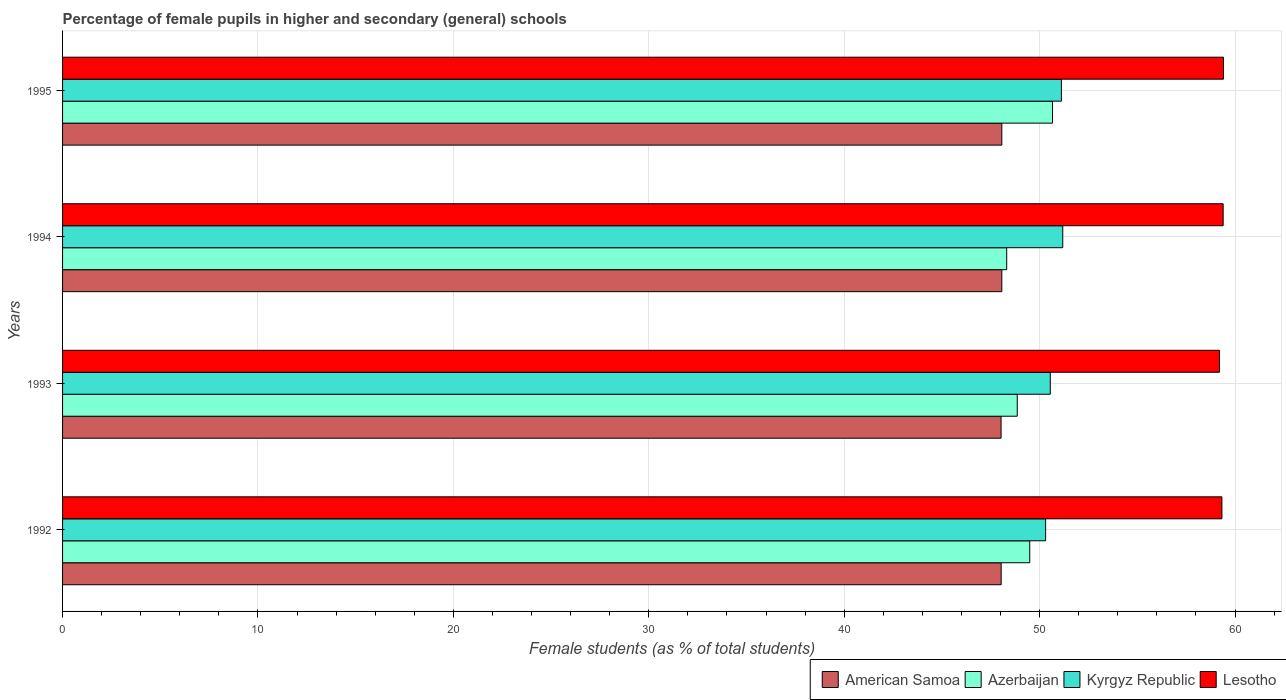How many different coloured bars are there?
Your answer should be very brief. 4. Are the number of bars per tick equal to the number of legend labels?
Offer a very short reply. Yes. Are the number of bars on each tick of the Y-axis equal?
Make the answer very short. Yes. What is the label of the 2nd group of bars from the top?
Provide a short and direct response. 1994. In how many cases, is the number of bars for a given year not equal to the number of legend labels?
Provide a short and direct response. 0. What is the percentage of female pupils in higher and secondary schools in Lesotho in 1992?
Your response must be concise. 59.33. Across all years, what is the maximum percentage of female pupils in higher and secondary schools in Lesotho?
Offer a terse response. 59.41. Across all years, what is the minimum percentage of female pupils in higher and secondary schools in Azerbaijan?
Give a very brief answer. 48.32. In which year was the percentage of female pupils in higher and secondary schools in American Samoa maximum?
Provide a short and direct response. 1994. What is the total percentage of female pupils in higher and secondary schools in Azerbaijan in the graph?
Ensure brevity in your answer.  197.33. What is the difference between the percentage of female pupils in higher and secondary schools in Kyrgyz Republic in 1992 and that in 1993?
Keep it short and to the point. -0.24. What is the difference between the percentage of female pupils in higher and secondary schools in American Samoa in 1993 and the percentage of female pupils in higher and secondary schools in Azerbaijan in 1992?
Provide a succinct answer. -1.47. What is the average percentage of female pupils in higher and secondary schools in Azerbaijan per year?
Give a very brief answer. 49.33. In the year 1994, what is the difference between the percentage of female pupils in higher and secondary schools in American Samoa and percentage of female pupils in higher and secondary schools in Azerbaijan?
Provide a succinct answer. -0.25. In how many years, is the percentage of female pupils in higher and secondary schools in Kyrgyz Republic greater than 12 %?
Make the answer very short. 4. What is the ratio of the percentage of female pupils in higher and secondary schools in Kyrgyz Republic in 1994 to that in 1995?
Keep it short and to the point. 1. Is the percentage of female pupils in higher and secondary schools in Azerbaijan in 1992 less than that in 1995?
Offer a terse response. Yes. What is the difference between the highest and the second highest percentage of female pupils in higher and secondary schools in Azerbaijan?
Offer a terse response. 1.17. What is the difference between the highest and the lowest percentage of female pupils in higher and secondary schools in Azerbaijan?
Provide a short and direct response. 2.34. In how many years, is the percentage of female pupils in higher and secondary schools in Azerbaijan greater than the average percentage of female pupils in higher and secondary schools in Azerbaijan taken over all years?
Provide a succinct answer. 2. Is the sum of the percentage of female pupils in higher and secondary schools in American Samoa in 1992 and 1994 greater than the maximum percentage of female pupils in higher and secondary schools in Kyrgyz Republic across all years?
Your response must be concise. Yes. Is it the case that in every year, the sum of the percentage of female pupils in higher and secondary schools in Kyrgyz Republic and percentage of female pupils in higher and secondary schools in Lesotho is greater than the sum of percentage of female pupils in higher and secondary schools in Azerbaijan and percentage of female pupils in higher and secondary schools in American Samoa?
Offer a terse response. Yes. What does the 4th bar from the top in 1993 represents?
Provide a short and direct response. American Samoa. What does the 1st bar from the bottom in 1993 represents?
Your answer should be very brief. American Samoa. Is it the case that in every year, the sum of the percentage of female pupils in higher and secondary schools in American Samoa and percentage of female pupils in higher and secondary schools in Azerbaijan is greater than the percentage of female pupils in higher and secondary schools in Lesotho?
Offer a very short reply. Yes. Are all the bars in the graph horizontal?
Offer a very short reply. Yes. How many years are there in the graph?
Offer a very short reply. 4. Does the graph contain any zero values?
Give a very brief answer. No. What is the title of the graph?
Ensure brevity in your answer.  Percentage of female pupils in higher and secondary (general) schools. Does "Upper middle income" appear as one of the legend labels in the graph?
Your response must be concise. No. What is the label or title of the X-axis?
Your answer should be very brief. Female students (as % of total students). What is the Female students (as % of total students) in American Samoa in 1992?
Make the answer very short. 48.03. What is the Female students (as % of total students) of Azerbaijan in 1992?
Your answer should be very brief. 49.5. What is the Female students (as % of total students) in Kyrgyz Republic in 1992?
Your response must be concise. 50.31. What is the Female students (as % of total students) of Lesotho in 1992?
Ensure brevity in your answer.  59.33. What is the Female students (as % of total students) of American Samoa in 1993?
Provide a short and direct response. 48.03. What is the Female students (as % of total students) of Azerbaijan in 1993?
Keep it short and to the point. 48.86. What is the Female students (as % of total students) in Kyrgyz Republic in 1993?
Make the answer very short. 50.55. What is the Female students (as % of total students) in Lesotho in 1993?
Keep it short and to the point. 59.2. What is the Female students (as % of total students) of American Samoa in 1994?
Provide a succinct answer. 48.07. What is the Female students (as % of total students) in Azerbaijan in 1994?
Your answer should be compact. 48.32. What is the Female students (as % of total students) of Kyrgyz Republic in 1994?
Offer a terse response. 51.18. What is the Female students (as % of total students) of Lesotho in 1994?
Offer a terse response. 59.39. What is the Female students (as % of total students) of American Samoa in 1995?
Your answer should be very brief. 48.07. What is the Female students (as % of total students) of Azerbaijan in 1995?
Provide a short and direct response. 50.66. What is the Female students (as % of total students) in Kyrgyz Republic in 1995?
Ensure brevity in your answer.  51.12. What is the Female students (as % of total students) of Lesotho in 1995?
Ensure brevity in your answer.  59.41. Across all years, what is the maximum Female students (as % of total students) of American Samoa?
Make the answer very short. 48.07. Across all years, what is the maximum Female students (as % of total students) of Azerbaijan?
Your answer should be very brief. 50.66. Across all years, what is the maximum Female students (as % of total students) of Kyrgyz Republic?
Ensure brevity in your answer.  51.18. Across all years, what is the maximum Female students (as % of total students) of Lesotho?
Provide a short and direct response. 59.41. Across all years, what is the minimum Female students (as % of total students) of American Samoa?
Offer a terse response. 48.03. Across all years, what is the minimum Female students (as % of total students) of Azerbaijan?
Keep it short and to the point. 48.32. Across all years, what is the minimum Female students (as % of total students) in Kyrgyz Republic?
Your response must be concise. 50.31. Across all years, what is the minimum Female students (as % of total students) of Lesotho?
Provide a short and direct response. 59.2. What is the total Female students (as % of total students) in American Samoa in the graph?
Your answer should be compact. 192.19. What is the total Female students (as % of total students) in Azerbaijan in the graph?
Your response must be concise. 197.33. What is the total Female students (as % of total students) in Kyrgyz Republic in the graph?
Your answer should be compact. 203.15. What is the total Female students (as % of total students) in Lesotho in the graph?
Offer a very short reply. 237.33. What is the difference between the Female students (as % of total students) of American Samoa in 1992 and that in 1993?
Your answer should be compact. 0.01. What is the difference between the Female students (as % of total students) in Azerbaijan in 1992 and that in 1993?
Offer a terse response. 0.64. What is the difference between the Female students (as % of total students) in Kyrgyz Republic in 1992 and that in 1993?
Provide a short and direct response. -0.24. What is the difference between the Female students (as % of total students) of Lesotho in 1992 and that in 1993?
Provide a short and direct response. 0.13. What is the difference between the Female students (as % of total students) in American Samoa in 1992 and that in 1994?
Give a very brief answer. -0.03. What is the difference between the Female students (as % of total students) in Azerbaijan in 1992 and that in 1994?
Make the answer very short. 1.18. What is the difference between the Female students (as % of total students) of Kyrgyz Republic in 1992 and that in 1994?
Give a very brief answer. -0.88. What is the difference between the Female students (as % of total students) of Lesotho in 1992 and that in 1994?
Offer a terse response. -0.06. What is the difference between the Female students (as % of total students) of American Samoa in 1992 and that in 1995?
Keep it short and to the point. -0.03. What is the difference between the Female students (as % of total students) in Azerbaijan in 1992 and that in 1995?
Offer a terse response. -1.17. What is the difference between the Female students (as % of total students) of Kyrgyz Republic in 1992 and that in 1995?
Ensure brevity in your answer.  -0.81. What is the difference between the Female students (as % of total students) in Lesotho in 1992 and that in 1995?
Your answer should be compact. -0.08. What is the difference between the Female students (as % of total students) of American Samoa in 1993 and that in 1994?
Make the answer very short. -0.04. What is the difference between the Female students (as % of total students) of Azerbaijan in 1993 and that in 1994?
Your answer should be compact. 0.54. What is the difference between the Female students (as % of total students) of Kyrgyz Republic in 1993 and that in 1994?
Keep it short and to the point. -0.64. What is the difference between the Female students (as % of total students) in Lesotho in 1993 and that in 1994?
Provide a short and direct response. -0.19. What is the difference between the Female students (as % of total students) of American Samoa in 1993 and that in 1995?
Offer a very short reply. -0.04. What is the difference between the Female students (as % of total students) in Azerbaijan in 1993 and that in 1995?
Ensure brevity in your answer.  -1.81. What is the difference between the Female students (as % of total students) in Kyrgyz Republic in 1993 and that in 1995?
Offer a terse response. -0.57. What is the difference between the Female students (as % of total students) in Lesotho in 1993 and that in 1995?
Keep it short and to the point. -0.2. What is the difference between the Female students (as % of total students) in American Samoa in 1994 and that in 1995?
Ensure brevity in your answer.  0. What is the difference between the Female students (as % of total students) of Azerbaijan in 1994 and that in 1995?
Your answer should be compact. -2.34. What is the difference between the Female students (as % of total students) in Kyrgyz Republic in 1994 and that in 1995?
Keep it short and to the point. 0.07. What is the difference between the Female students (as % of total students) in Lesotho in 1994 and that in 1995?
Make the answer very short. -0.01. What is the difference between the Female students (as % of total students) in American Samoa in 1992 and the Female students (as % of total students) in Azerbaijan in 1993?
Your response must be concise. -0.82. What is the difference between the Female students (as % of total students) in American Samoa in 1992 and the Female students (as % of total students) in Kyrgyz Republic in 1993?
Offer a terse response. -2.51. What is the difference between the Female students (as % of total students) in American Samoa in 1992 and the Female students (as % of total students) in Lesotho in 1993?
Your answer should be very brief. -11.17. What is the difference between the Female students (as % of total students) of Azerbaijan in 1992 and the Female students (as % of total students) of Kyrgyz Republic in 1993?
Your answer should be very brief. -1.05. What is the difference between the Female students (as % of total students) of Azerbaijan in 1992 and the Female students (as % of total students) of Lesotho in 1993?
Keep it short and to the point. -9.71. What is the difference between the Female students (as % of total students) of Kyrgyz Republic in 1992 and the Female students (as % of total students) of Lesotho in 1993?
Give a very brief answer. -8.9. What is the difference between the Female students (as % of total students) of American Samoa in 1992 and the Female students (as % of total students) of Azerbaijan in 1994?
Give a very brief answer. -0.28. What is the difference between the Female students (as % of total students) in American Samoa in 1992 and the Female students (as % of total students) in Kyrgyz Republic in 1994?
Keep it short and to the point. -3.15. What is the difference between the Female students (as % of total students) of American Samoa in 1992 and the Female students (as % of total students) of Lesotho in 1994?
Your answer should be compact. -11.36. What is the difference between the Female students (as % of total students) of Azerbaijan in 1992 and the Female students (as % of total students) of Kyrgyz Republic in 1994?
Provide a short and direct response. -1.69. What is the difference between the Female students (as % of total students) in Azerbaijan in 1992 and the Female students (as % of total students) in Lesotho in 1994?
Keep it short and to the point. -9.9. What is the difference between the Female students (as % of total students) of Kyrgyz Republic in 1992 and the Female students (as % of total students) of Lesotho in 1994?
Your response must be concise. -9.08. What is the difference between the Female students (as % of total students) of American Samoa in 1992 and the Female students (as % of total students) of Azerbaijan in 1995?
Your response must be concise. -2.63. What is the difference between the Female students (as % of total students) in American Samoa in 1992 and the Female students (as % of total students) in Kyrgyz Republic in 1995?
Offer a terse response. -3.08. What is the difference between the Female students (as % of total students) of American Samoa in 1992 and the Female students (as % of total students) of Lesotho in 1995?
Offer a very short reply. -11.37. What is the difference between the Female students (as % of total students) of Azerbaijan in 1992 and the Female students (as % of total students) of Kyrgyz Republic in 1995?
Your response must be concise. -1.62. What is the difference between the Female students (as % of total students) in Azerbaijan in 1992 and the Female students (as % of total students) in Lesotho in 1995?
Make the answer very short. -9.91. What is the difference between the Female students (as % of total students) in Kyrgyz Republic in 1992 and the Female students (as % of total students) in Lesotho in 1995?
Your answer should be compact. -9.1. What is the difference between the Female students (as % of total students) in American Samoa in 1993 and the Female students (as % of total students) in Azerbaijan in 1994?
Offer a terse response. -0.29. What is the difference between the Female students (as % of total students) in American Samoa in 1993 and the Female students (as % of total students) in Kyrgyz Republic in 1994?
Provide a succinct answer. -3.16. What is the difference between the Female students (as % of total students) of American Samoa in 1993 and the Female students (as % of total students) of Lesotho in 1994?
Your answer should be very brief. -11.36. What is the difference between the Female students (as % of total students) of Azerbaijan in 1993 and the Female students (as % of total students) of Kyrgyz Republic in 1994?
Ensure brevity in your answer.  -2.33. What is the difference between the Female students (as % of total students) of Azerbaijan in 1993 and the Female students (as % of total students) of Lesotho in 1994?
Ensure brevity in your answer.  -10.54. What is the difference between the Female students (as % of total students) of Kyrgyz Republic in 1993 and the Female students (as % of total students) of Lesotho in 1994?
Offer a very short reply. -8.85. What is the difference between the Female students (as % of total students) of American Samoa in 1993 and the Female students (as % of total students) of Azerbaijan in 1995?
Your answer should be compact. -2.63. What is the difference between the Female students (as % of total students) of American Samoa in 1993 and the Female students (as % of total students) of Kyrgyz Republic in 1995?
Offer a very short reply. -3.09. What is the difference between the Female students (as % of total students) in American Samoa in 1993 and the Female students (as % of total students) in Lesotho in 1995?
Your answer should be compact. -11.38. What is the difference between the Female students (as % of total students) in Azerbaijan in 1993 and the Female students (as % of total students) in Kyrgyz Republic in 1995?
Provide a short and direct response. -2.26. What is the difference between the Female students (as % of total students) in Azerbaijan in 1993 and the Female students (as % of total students) in Lesotho in 1995?
Keep it short and to the point. -10.55. What is the difference between the Female students (as % of total students) in Kyrgyz Republic in 1993 and the Female students (as % of total students) in Lesotho in 1995?
Make the answer very short. -8.86. What is the difference between the Female students (as % of total students) in American Samoa in 1994 and the Female students (as % of total students) in Azerbaijan in 1995?
Your answer should be compact. -2.59. What is the difference between the Female students (as % of total students) in American Samoa in 1994 and the Female students (as % of total students) in Kyrgyz Republic in 1995?
Offer a very short reply. -3.05. What is the difference between the Female students (as % of total students) in American Samoa in 1994 and the Female students (as % of total students) in Lesotho in 1995?
Your answer should be very brief. -11.34. What is the difference between the Female students (as % of total students) of Azerbaijan in 1994 and the Female students (as % of total students) of Kyrgyz Republic in 1995?
Give a very brief answer. -2.8. What is the difference between the Female students (as % of total students) of Azerbaijan in 1994 and the Female students (as % of total students) of Lesotho in 1995?
Provide a succinct answer. -11.09. What is the difference between the Female students (as % of total students) in Kyrgyz Republic in 1994 and the Female students (as % of total students) in Lesotho in 1995?
Offer a terse response. -8.22. What is the average Female students (as % of total students) in American Samoa per year?
Make the answer very short. 48.05. What is the average Female students (as % of total students) in Azerbaijan per year?
Your answer should be very brief. 49.33. What is the average Female students (as % of total students) in Kyrgyz Republic per year?
Ensure brevity in your answer.  50.79. What is the average Female students (as % of total students) of Lesotho per year?
Offer a very short reply. 59.33. In the year 1992, what is the difference between the Female students (as % of total students) of American Samoa and Female students (as % of total students) of Azerbaijan?
Your answer should be very brief. -1.46. In the year 1992, what is the difference between the Female students (as % of total students) in American Samoa and Female students (as % of total students) in Kyrgyz Republic?
Your answer should be very brief. -2.27. In the year 1992, what is the difference between the Female students (as % of total students) of American Samoa and Female students (as % of total students) of Lesotho?
Provide a short and direct response. -11.3. In the year 1992, what is the difference between the Female students (as % of total students) of Azerbaijan and Female students (as % of total students) of Kyrgyz Republic?
Ensure brevity in your answer.  -0.81. In the year 1992, what is the difference between the Female students (as % of total students) of Azerbaijan and Female students (as % of total students) of Lesotho?
Your answer should be compact. -9.83. In the year 1992, what is the difference between the Female students (as % of total students) in Kyrgyz Republic and Female students (as % of total students) in Lesotho?
Your answer should be compact. -9.02. In the year 1993, what is the difference between the Female students (as % of total students) in American Samoa and Female students (as % of total students) in Azerbaijan?
Your response must be concise. -0.83. In the year 1993, what is the difference between the Female students (as % of total students) of American Samoa and Female students (as % of total students) of Kyrgyz Republic?
Your response must be concise. -2.52. In the year 1993, what is the difference between the Female students (as % of total students) of American Samoa and Female students (as % of total students) of Lesotho?
Offer a terse response. -11.18. In the year 1993, what is the difference between the Female students (as % of total students) in Azerbaijan and Female students (as % of total students) in Kyrgyz Republic?
Keep it short and to the point. -1.69. In the year 1993, what is the difference between the Female students (as % of total students) of Azerbaijan and Female students (as % of total students) of Lesotho?
Keep it short and to the point. -10.35. In the year 1993, what is the difference between the Female students (as % of total students) of Kyrgyz Republic and Female students (as % of total students) of Lesotho?
Your response must be concise. -8.66. In the year 1994, what is the difference between the Female students (as % of total students) of American Samoa and Female students (as % of total students) of Azerbaijan?
Keep it short and to the point. -0.25. In the year 1994, what is the difference between the Female students (as % of total students) in American Samoa and Female students (as % of total students) in Kyrgyz Republic?
Provide a succinct answer. -3.12. In the year 1994, what is the difference between the Female students (as % of total students) in American Samoa and Female students (as % of total students) in Lesotho?
Your answer should be compact. -11.33. In the year 1994, what is the difference between the Female students (as % of total students) of Azerbaijan and Female students (as % of total students) of Kyrgyz Republic?
Give a very brief answer. -2.87. In the year 1994, what is the difference between the Female students (as % of total students) of Azerbaijan and Female students (as % of total students) of Lesotho?
Your answer should be very brief. -11.08. In the year 1994, what is the difference between the Female students (as % of total students) in Kyrgyz Republic and Female students (as % of total students) in Lesotho?
Provide a succinct answer. -8.21. In the year 1995, what is the difference between the Female students (as % of total students) in American Samoa and Female students (as % of total students) in Azerbaijan?
Offer a very short reply. -2.59. In the year 1995, what is the difference between the Female students (as % of total students) of American Samoa and Female students (as % of total students) of Kyrgyz Republic?
Your response must be concise. -3.05. In the year 1995, what is the difference between the Female students (as % of total students) of American Samoa and Female students (as % of total students) of Lesotho?
Your answer should be very brief. -11.34. In the year 1995, what is the difference between the Female students (as % of total students) of Azerbaijan and Female students (as % of total students) of Kyrgyz Republic?
Provide a short and direct response. -0.45. In the year 1995, what is the difference between the Female students (as % of total students) of Azerbaijan and Female students (as % of total students) of Lesotho?
Your response must be concise. -8.75. In the year 1995, what is the difference between the Female students (as % of total students) of Kyrgyz Republic and Female students (as % of total students) of Lesotho?
Make the answer very short. -8.29. What is the ratio of the Female students (as % of total students) in Azerbaijan in 1992 to that in 1993?
Provide a succinct answer. 1.01. What is the ratio of the Female students (as % of total students) in Kyrgyz Republic in 1992 to that in 1993?
Your answer should be very brief. 1. What is the ratio of the Female students (as % of total students) of Lesotho in 1992 to that in 1993?
Your response must be concise. 1. What is the ratio of the Female students (as % of total students) in American Samoa in 1992 to that in 1994?
Keep it short and to the point. 1. What is the ratio of the Female students (as % of total students) in Azerbaijan in 1992 to that in 1994?
Your response must be concise. 1.02. What is the ratio of the Female students (as % of total students) in Kyrgyz Republic in 1992 to that in 1994?
Ensure brevity in your answer.  0.98. What is the ratio of the Female students (as % of total students) in Lesotho in 1992 to that in 1994?
Your answer should be very brief. 1. What is the ratio of the Female students (as % of total students) of Kyrgyz Republic in 1992 to that in 1995?
Your answer should be compact. 0.98. What is the ratio of the Female students (as % of total students) of Lesotho in 1992 to that in 1995?
Provide a succinct answer. 1. What is the ratio of the Female students (as % of total students) of American Samoa in 1993 to that in 1994?
Offer a terse response. 1. What is the ratio of the Female students (as % of total students) in Azerbaijan in 1993 to that in 1994?
Keep it short and to the point. 1.01. What is the ratio of the Female students (as % of total students) of Kyrgyz Republic in 1993 to that in 1994?
Provide a succinct answer. 0.99. What is the ratio of the Female students (as % of total students) of American Samoa in 1993 to that in 1995?
Keep it short and to the point. 1. What is the ratio of the Female students (as % of total students) of Azerbaijan in 1993 to that in 1995?
Provide a short and direct response. 0.96. What is the ratio of the Female students (as % of total students) of Kyrgyz Republic in 1993 to that in 1995?
Your answer should be compact. 0.99. What is the ratio of the Female students (as % of total students) of American Samoa in 1994 to that in 1995?
Provide a succinct answer. 1. What is the ratio of the Female students (as % of total students) of Azerbaijan in 1994 to that in 1995?
Provide a succinct answer. 0.95. What is the ratio of the Female students (as % of total students) in Kyrgyz Republic in 1994 to that in 1995?
Your answer should be compact. 1. What is the ratio of the Female students (as % of total students) in Lesotho in 1994 to that in 1995?
Ensure brevity in your answer.  1. What is the difference between the highest and the second highest Female students (as % of total students) of American Samoa?
Give a very brief answer. 0. What is the difference between the highest and the second highest Female students (as % of total students) in Azerbaijan?
Your answer should be very brief. 1.17. What is the difference between the highest and the second highest Female students (as % of total students) of Kyrgyz Republic?
Make the answer very short. 0.07. What is the difference between the highest and the second highest Female students (as % of total students) in Lesotho?
Provide a succinct answer. 0.01. What is the difference between the highest and the lowest Female students (as % of total students) in American Samoa?
Your answer should be very brief. 0.04. What is the difference between the highest and the lowest Female students (as % of total students) in Azerbaijan?
Your response must be concise. 2.34. What is the difference between the highest and the lowest Female students (as % of total students) in Kyrgyz Republic?
Ensure brevity in your answer.  0.88. What is the difference between the highest and the lowest Female students (as % of total students) of Lesotho?
Ensure brevity in your answer.  0.2. 